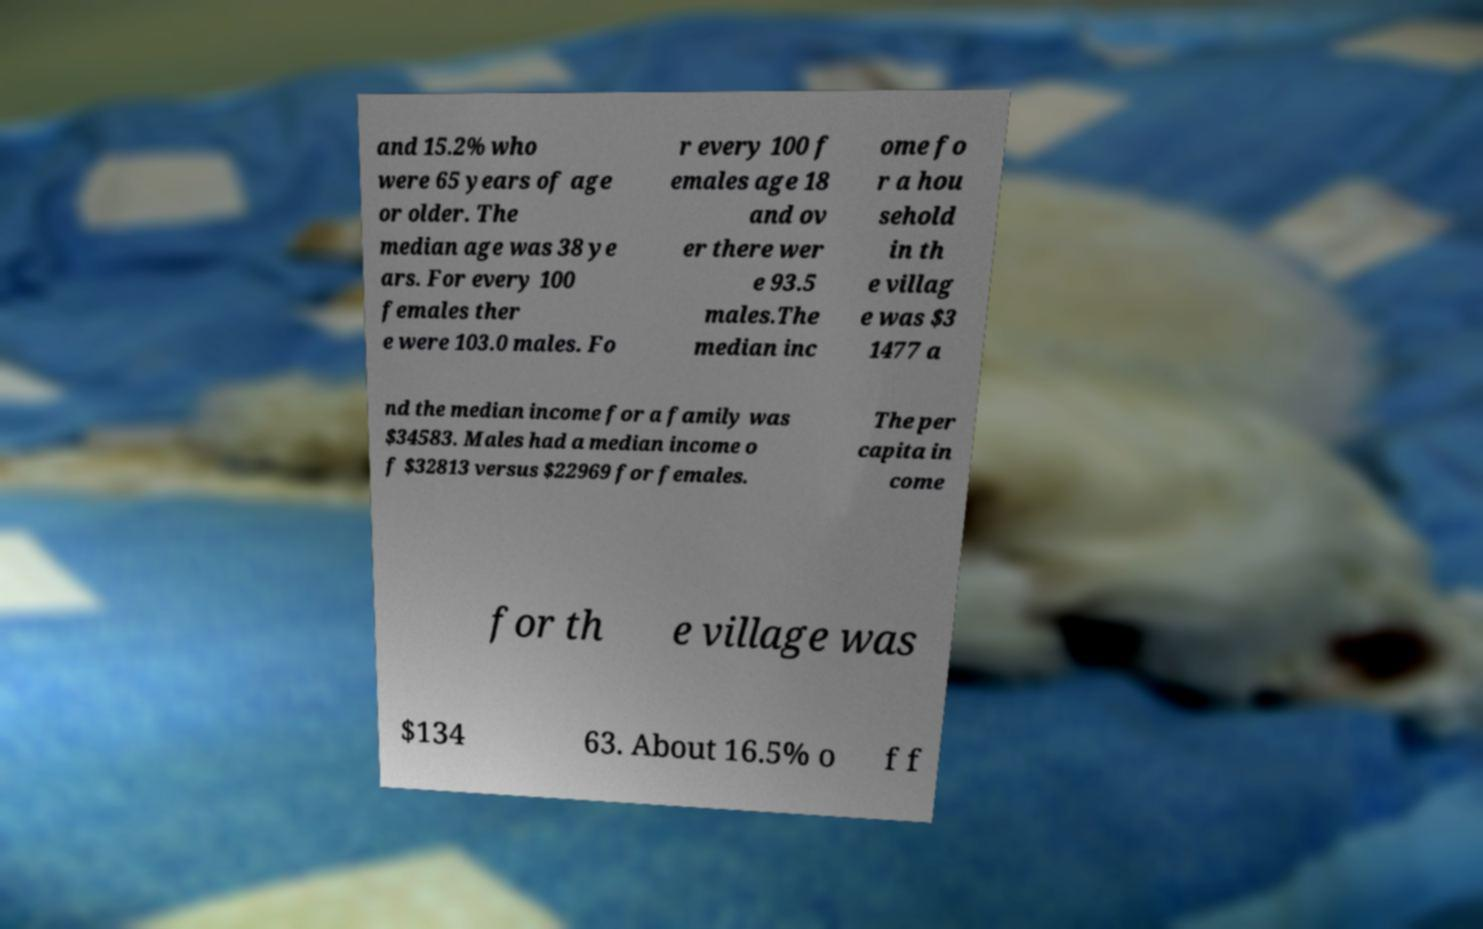What messages or text are displayed in this image? I need them in a readable, typed format. and 15.2% who were 65 years of age or older. The median age was 38 ye ars. For every 100 females ther e were 103.0 males. Fo r every 100 f emales age 18 and ov er there wer e 93.5 males.The median inc ome fo r a hou sehold in th e villag e was $3 1477 a nd the median income for a family was $34583. Males had a median income o f $32813 versus $22969 for females. The per capita in come for th e village was $134 63. About 16.5% o f f 